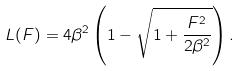Convert formula to latex. <formula><loc_0><loc_0><loc_500><loc_500>L ( F ) = 4 \beta ^ { 2 } \left ( 1 - \sqrt { 1 + \frac { F ^ { 2 } } { 2 \beta ^ { 2 } } } \right ) .</formula> 